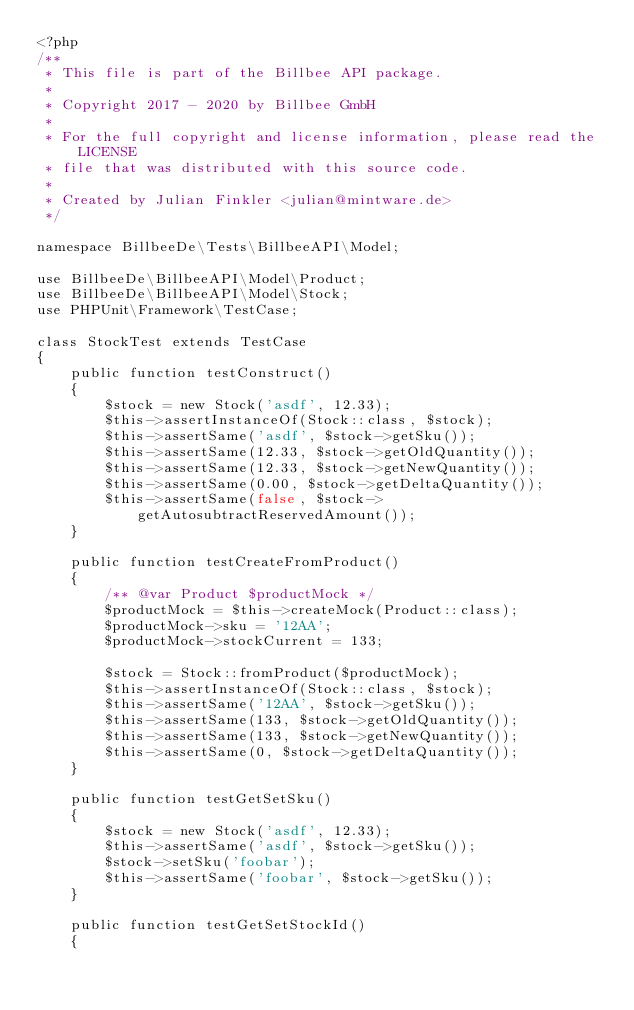Convert code to text. <code><loc_0><loc_0><loc_500><loc_500><_PHP_><?php
/**
 * This file is part of the Billbee API package.
 *
 * Copyright 2017 - 2020 by Billbee GmbH
 *
 * For the full copyright and license information, please read the LICENSE
 * file that was distributed with this source code.
 *
 * Created by Julian Finkler <julian@mintware.de>
 */

namespace BillbeeDe\Tests\BillbeeAPI\Model;

use BillbeeDe\BillbeeAPI\Model\Product;
use BillbeeDe\BillbeeAPI\Model\Stock;
use PHPUnit\Framework\TestCase;

class StockTest extends TestCase
{
    public function testConstruct()
    {
        $stock = new Stock('asdf', 12.33);
        $this->assertInstanceOf(Stock::class, $stock);
        $this->assertSame('asdf', $stock->getSku());
        $this->assertSame(12.33, $stock->getOldQuantity());
        $this->assertSame(12.33, $stock->getNewQuantity());
        $this->assertSame(0.00, $stock->getDeltaQuantity());
        $this->assertSame(false, $stock->getAutosubtractReservedAmount());
    }

    public function testCreateFromProduct()
    {
        /** @var Product $productMock */
        $productMock = $this->createMock(Product::class);
        $productMock->sku = '12AA';
        $productMock->stockCurrent = 133;

        $stock = Stock::fromProduct($productMock);
        $this->assertInstanceOf(Stock::class, $stock);
        $this->assertSame('12AA', $stock->getSku());
        $this->assertSame(133, $stock->getOldQuantity());
        $this->assertSame(133, $stock->getNewQuantity());
        $this->assertSame(0, $stock->getDeltaQuantity());
    }

    public function testGetSetSku()
    {
        $stock = new Stock('asdf', 12.33);
        $this->assertSame('asdf', $stock->getSku());
        $stock->setSku('foobar');
        $this->assertSame('foobar', $stock->getSku());
    }

    public function testGetSetStockId()
    {</code> 